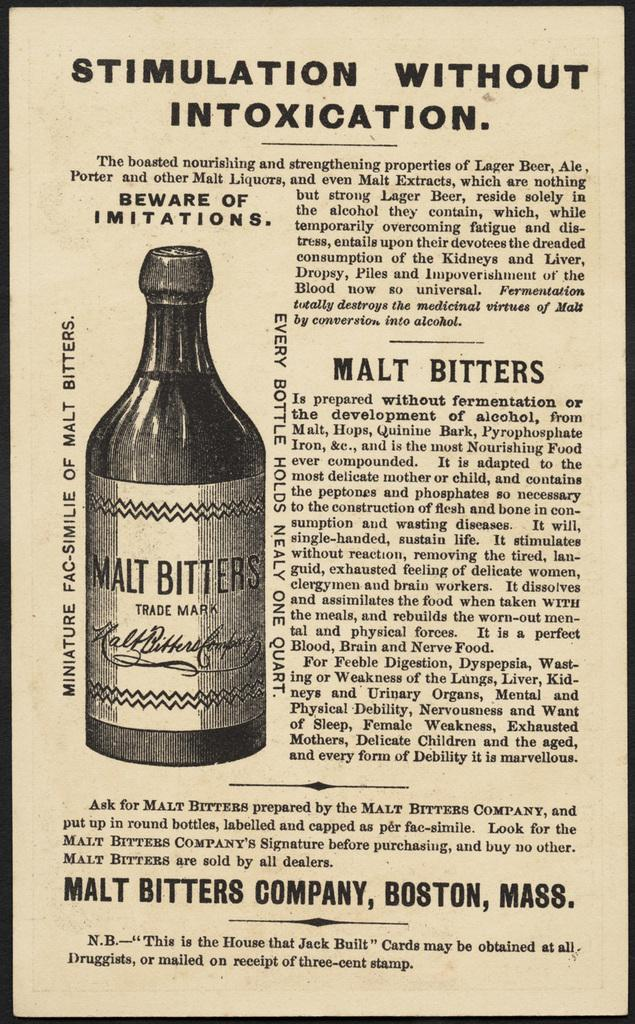<image>
Write a terse but informative summary of the picture. An old newspaper ad about stimulation without intoxication 